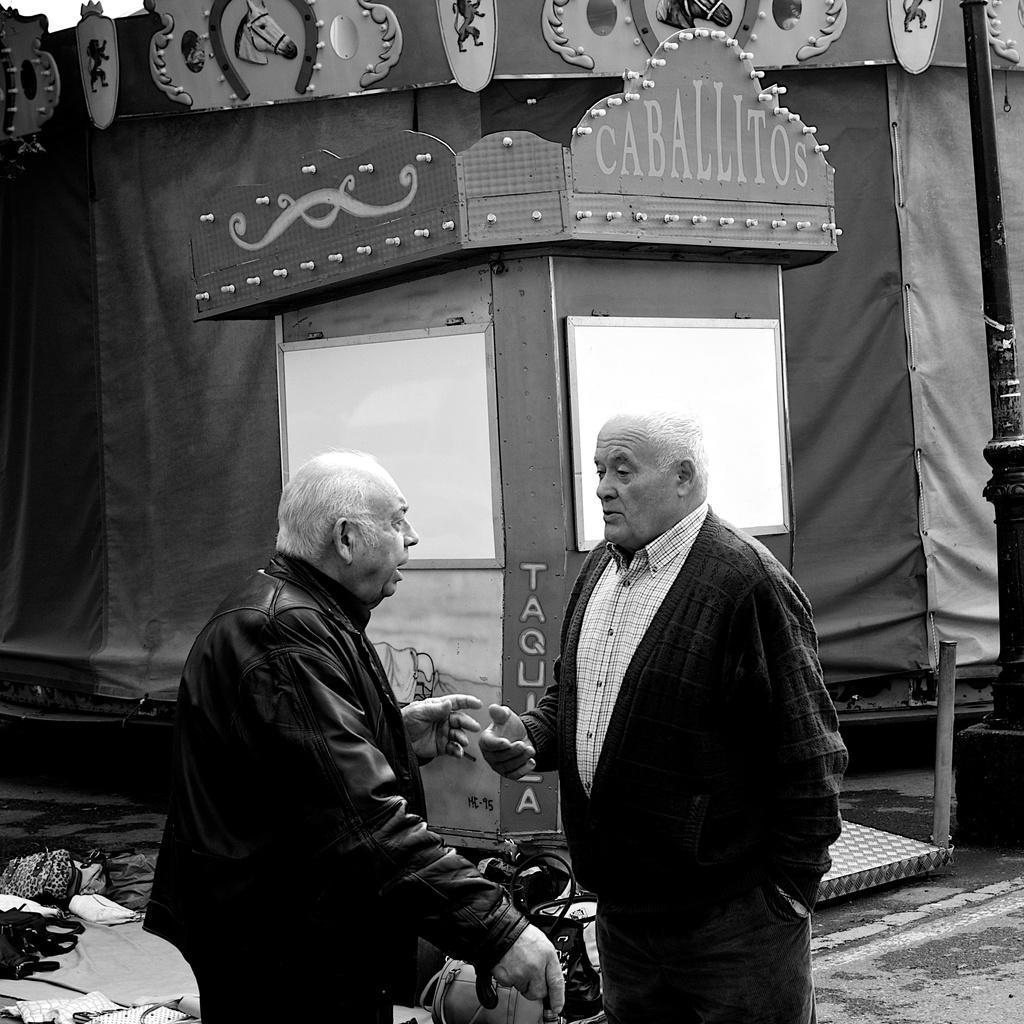Please provide a concise description of this image. There is a black and white image. In this image we can see two persons standing. Person on the left is holding something in the hand. On the left side there is a table. On that there are few items. In the back there is a tent. Also there is a small shed. On that something is written. On the right side there is a pole. 